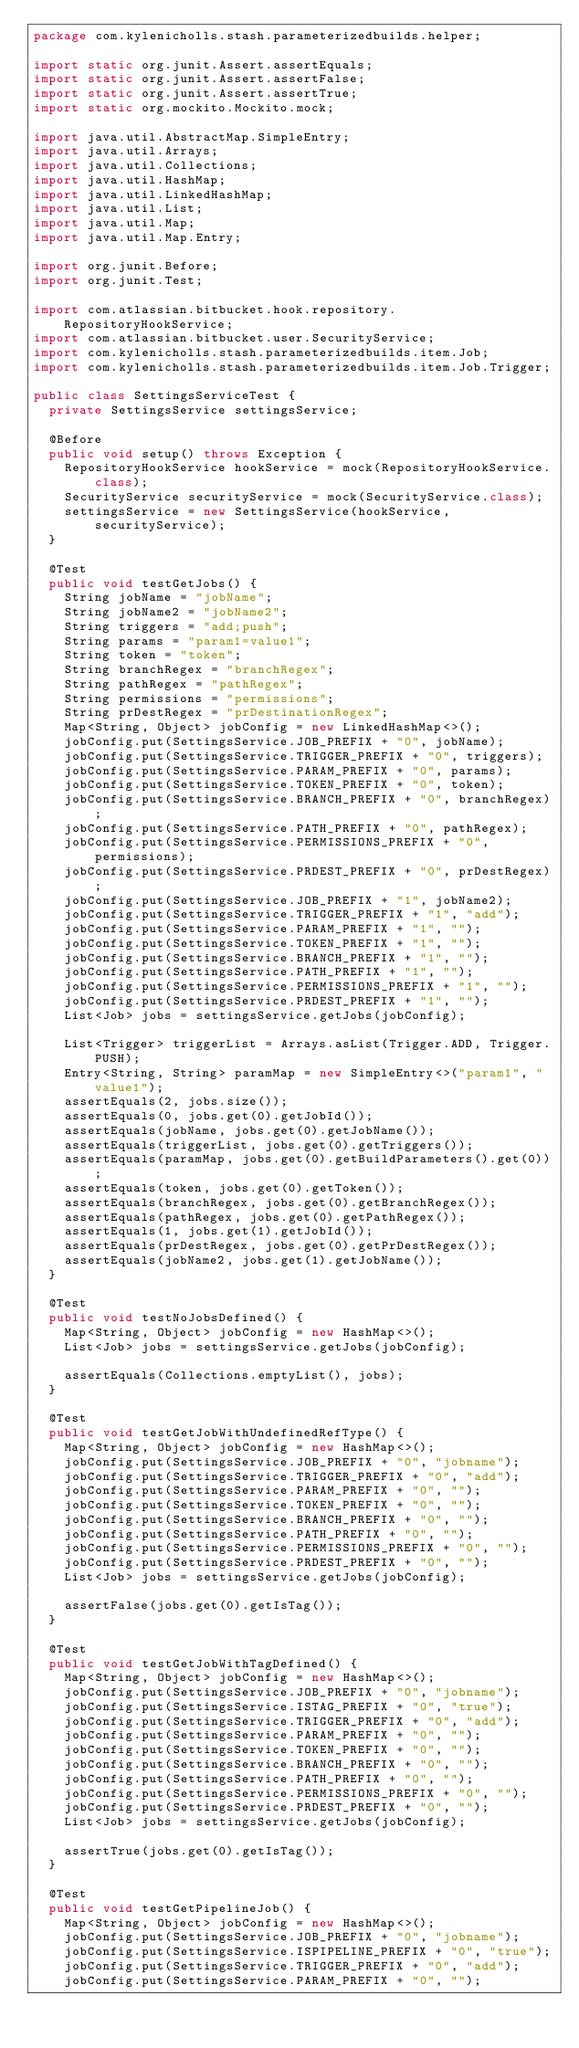<code> <loc_0><loc_0><loc_500><loc_500><_Java_>package com.kylenicholls.stash.parameterizedbuilds.helper;

import static org.junit.Assert.assertEquals;
import static org.junit.Assert.assertFalse;
import static org.junit.Assert.assertTrue;
import static org.mockito.Mockito.mock;

import java.util.AbstractMap.SimpleEntry;
import java.util.Arrays;
import java.util.Collections;
import java.util.HashMap;
import java.util.LinkedHashMap;
import java.util.List;
import java.util.Map;
import java.util.Map.Entry;

import org.junit.Before;
import org.junit.Test;

import com.atlassian.bitbucket.hook.repository.RepositoryHookService;
import com.atlassian.bitbucket.user.SecurityService;
import com.kylenicholls.stash.parameterizedbuilds.item.Job;
import com.kylenicholls.stash.parameterizedbuilds.item.Job.Trigger;

public class SettingsServiceTest {
	private SettingsService settingsService;

	@Before
	public void setup() throws Exception {
		RepositoryHookService hookService = mock(RepositoryHookService.class);
		SecurityService securityService = mock(SecurityService.class);
		settingsService = new SettingsService(hookService, securityService);
	}

	@Test
	public void testGetJobs() {
		String jobName = "jobName";
		String jobName2 = "jobName2";
		String triggers = "add;push";
		String params = "param1=value1";
		String token = "token";
		String branchRegex = "branchRegex";
		String pathRegex = "pathRegex";
		String permissions = "permissions";
		String prDestRegex = "prDestinationRegex";
		Map<String, Object> jobConfig = new LinkedHashMap<>();
		jobConfig.put(SettingsService.JOB_PREFIX + "0", jobName);
		jobConfig.put(SettingsService.TRIGGER_PREFIX + "0", triggers);
		jobConfig.put(SettingsService.PARAM_PREFIX + "0", params);
		jobConfig.put(SettingsService.TOKEN_PREFIX + "0", token);
		jobConfig.put(SettingsService.BRANCH_PREFIX + "0", branchRegex);
		jobConfig.put(SettingsService.PATH_PREFIX + "0", pathRegex);
		jobConfig.put(SettingsService.PERMISSIONS_PREFIX + "0", permissions);
		jobConfig.put(SettingsService.PRDEST_PREFIX + "0", prDestRegex);
		jobConfig.put(SettingsService.JOB_PREFIX + "1", jobName2);
		jobConfig.put(SettingsService.TRIGGER_PREFIX + "1", "add");
		jobConfig.put(SettingsService.PARAM_PREFIX + "1", "");
		jobConfig.put(SettingsService.TOKEN_PREFIX + "1", "");
		jobConfig.put(SettingsService.BRANCH_PREFIX + "1", "");
		jobConfig.put(SettingsService.PATH_PREFIX + "1", "");
		jobConfig.put(SettingsService.PERMISSIONS_PREFIX + "1", "");
		jobConfig.put(SettingsService.PRDEST_PREFIX + "1", "");
		List<Job> jobs = settingsService.getJobs(jobConfig);

		List<Trigger> triggerList = Arrays.asList(Trigger.ADD, Trigger.PUSH);
		Entry<String, String> paramMap = new SimpleEntry<>("param1", "value1");
		assertEquals(2, jobs.size());
		assertEquals(0, jobs.get(0).getJobId());
		assertEquals(jobName, jobs.get(0).getJobName());
		assertEquals(triggerList, jobs.get(0).getTriggers());
		assertEquals(paramMap, jobs.get(0).getBuildParameters().get(0));
		assertEquals(token, jobs.get(0).getToken());
		assertEquals(branchRegex, jobs.get(0).getBranchRegex());
		assertEquals(pathRegex, jobs.get(0).getPathRegex());
		assertEquals(1, jobs.get(1).getJobId());
		assertEquals(prDestRegex, jobs.get(0).getPrDestRegex());
		assertEquals(jobName2, jobs.get(1).getJobName());
	}

	@Test
	public void testNoJobsDefined() {
		Map<String, Object> jobConfig = new HashMap<>();
		List<Job> jobs = settingsService.getJobs(jobConfig);

		assertEquals(Collections.emptyList(), jobs);
	}

	@Test
	public void testGetJobWithUndefinedRefType() {
		Map<String, Object> jobConfig = new HashMap<>();
		jobConfig.put(SettingsService.JOB_PREFIX + "0", "jobname");
		jobConfig.put(SettingsService.TRIGGER_PREFIX + "0", "add");
		jobConfig.put(SettingsService.PARAM_PREFIX + "0", "");
		jobConfig.put(SettingsService.TOKEN_PREFIX + "0", "");
		jobConfig.put(SettingsService.BRANCH_PREFIX + "0", "");
		jobConfig.put(SettingsService.PATH_PREFIX + "0", "");
		jobConfig.put(SettingsService.PERMISSIONS_PREFIX + "0", "");
		jobConfig.put(SettingsService.PRDEST_PREFIX + "0", "");
		List<Job> jobs = settingsService.getJobs(jobConfig);

		assertFalse(jobs.get(0).getIsTag());
	}

	@Test
	public void testGetJobWithTagDefined() {
		Map<String, Object> jobConfig = new HashMap<>();
		jobConfig.put(SettingsService.JOB_PREFIX + "0", "jobname");
		jobConfig.put(SettingsService.ISTAG_PREFIX + "0", "true");
		jobConfig.put(SettingsService.TRIGGER_PREFIX + "0", "add");
		jobConfig.put(SettingsService.PARAM_PREFIX + "0", "");
		jobConfig.put(SettingsService.TOKEN_PREFIX + "0", "");
		jobConfig.put(SettingsService.BRANCH_PREFIX + "0", "");
		jobConfig.put(SettingsService.PATH_PREFIX + "0", "");
		jobConfig.put(SettingsService.PERMISSIONS_PREFIX + "0", "");
		jobConfig.put(SettingsService.PRDEST_PREFIX + "0", "");
		List<Job> jobs = settingsService.getJobs(jobConfig);

		assertTrue(jobs.get(0).getIsTag());
	}

	@Test
	public void testGetPipelineJob() {
		Map<String, Object> jobConfig = new HashMap<>();
		jobConfig.put(SettingsService.JOB_PREFIX + "0", "jobname");
		jobConfig.put(SettingsService.ISPIPELINE_PREFIX + "0", "true");
		jobConfig.put(SettingsService.TRIGGER_PREFIX + "0", "add");
		jobConfig.put(SettingsService.PARAM_PREFIX + "0", "");</code> 